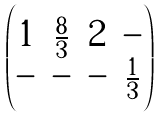Convert formula to latex. <formula><loc_0><loc_0><loc_500><loc_500>\begin{pmatrix} 1 & \frac { 8 } { 3 } & 2 & - \\ - & - & - & \frac { 1 } { 3 } \end{pmatrix}</formula> 